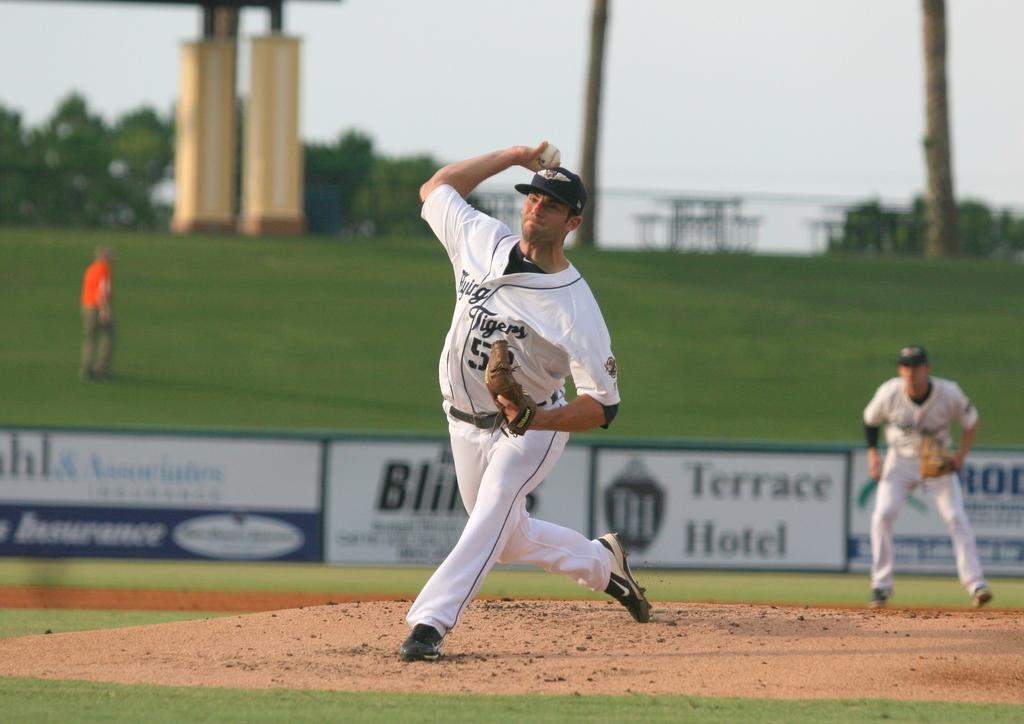<image>
Relay a brief, clear account of the picture shown. Professional baseball players near the back fence of the field with an advertisement for Terrace Hotel on it. 